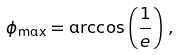<formula> <loc_0><loc_0><loc_500><loc_500>\phi _ { \max } = \arccos \left ( \frac { 1 } { e } \right ) \, ,</formula> 